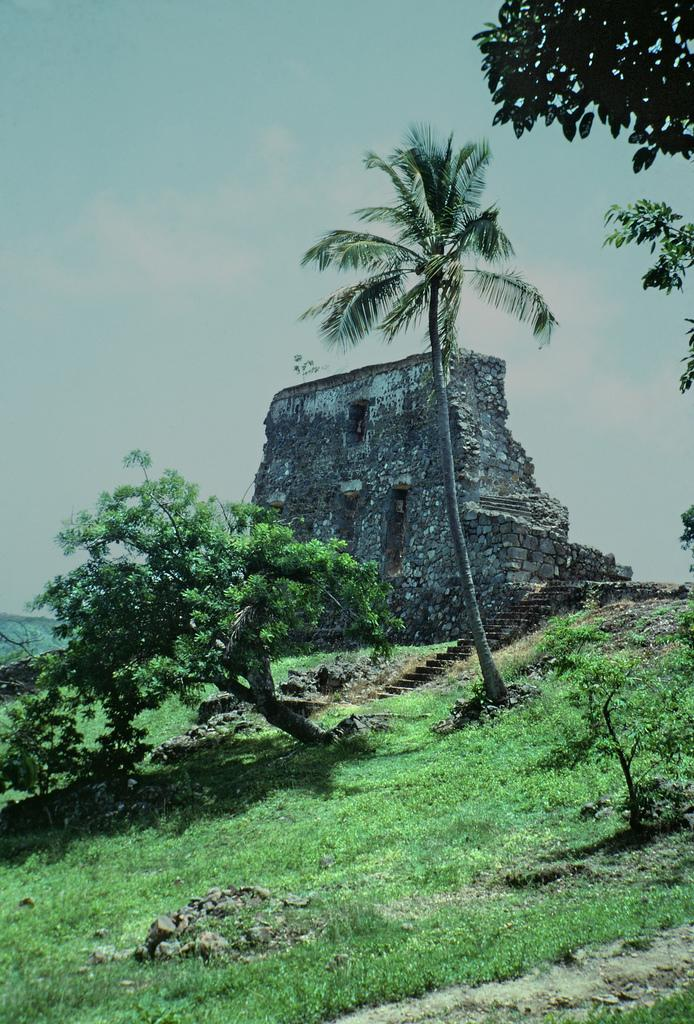What type of vegetation can be seen in the image? There is grass in the image. What other natural elements are present in the image? There are trees in the image. What is the man-made structure in the image? There is a wall in the image. What can be seen in the distance in the image? The sky is visible in the background of the image. Can you tell me how many beans are on the tree in the image? There are no beans present in the image; it features grass, trees, a wall, and the sky. What type of order is being followed by the goose in the image? There is no goose present in the image, so it is not possible to determine if any order is being followed. 